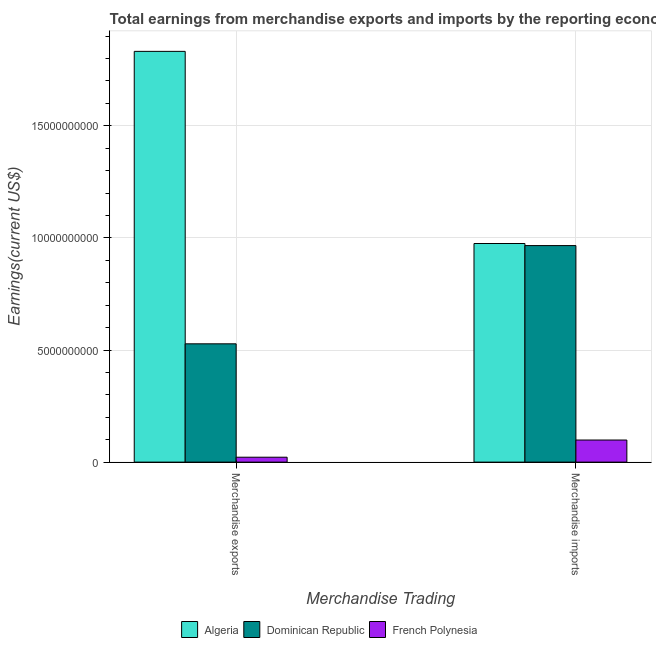Are the number of bars on each tick of the X-axis equal?
Give a very brief answer. Yes. How many bars are there on the 2nd tick from the left?
Provide a succinct answer. 3. How many bars are there on the 2nd tick from the right?
Make the answer very short. 3. What is the label of the 1st group of bars from the left?
Provide a short and direct response. Merchandise exports. What is the earnings from merchandise imports in Dominican Republic?
Provide a short and direct response. 9.66e+09. Across all countries, what is the maximum earnings from merchandise imports?
Keep it short and to the point. 9.75e+09. Across all countries, what is the minimum earnings from merchandise exports?
Make the answer very short. 2.19e+08. In which country was the earnings from merchandise imports maximum?
Your answer should be very brief. Algeria. In which country was the earnings from merchandise imports minimum?
Your response must be concise. French Polynesia. What is the total earnings from merchandise imports in the graph?
Ensure brevity in your answer.  2.04e+1. What is the difference between the earnings from merchandise exports in Algeria and that in Dominican Republic?
Your answer should be compact. 1.30e+1. What is the difference between the earnings from merchandise imports in Dominican Republic and the earnings from merchandise exports in Algeria?
Ensure brevity in your answer.  -8.66e+09. What is the average earnings from merchandise imports per country?
Provide a short and direct response. 6.80e+09. What is the difference between the earnings from merchandise imports and earnings from merchandise exports in Algeria?
Your response must be concise. -8.57e+09. In how many countries, is the earnings from merchandise imports greater than 11000000000 US$?
Offer a very short reply. 0. What is the ratio of the earnings from merchandise exports in French Polynesia to that in Dominican Republic?
Keep it short and to the point. 0.04. In how many countries, is the earnings from merchandise imports greater than the average earnings from merchandise imports taken over all countries?
Your response must be concise. 2. What does the 1st bar from the left in Merchandise exports represents?
Make the answer very short. Algeria. What does the 1st bar from the right in Merchandise exports represents?
Make the answer very short. French Polynesia. How many bars are there?
Make the answer very short. 6. Are all the bars in the graph horizontal?
Offer a terse response. No. How many countries are there in the graph?
Keep it short and to the point. 3. What is the difference between two consecutive major ticks on the Y-axis?
Offer a terse response. 5.00e+09. Are the values on the major ticks of Y-axis written in scientific E-notation?
Make the answer very short. No. Does the graph contain any zero values?
Offer a very short reply. No. Does the graph contain grids?
Give a very brief answer. Yes. Where does the legend appear in the graph?
Provide a short and direct response. Bottom center. What is the title of the graph?
Your answer should be very brief. Total earnings from merchandise exports and imports by the reporting economy in 2001. Does "Macao" appear as one of the legend labels in the graph?
Offer a very short reply. No. What is the label or title of the X-axis?
Your answer should be compact. Merchandise Trading. What is the label or title of the Y-axis?
Offer a very short reply. Earnings(current US$). What is the Earnings(current US$) of Algeria in Merchandise exports?
Your answer should be very brief. 1.83e+1. What is the Earnings(current US$) in Dominican Republic in Merchandise exports?
Your answer should be very brief. 5.28e+09. What is the Earnings(current US$) of French Polynesia in Merchandise exports?
Your response must be concise. 2.19e+08. What is the Earnings(current US$) of Algeria in Merchandise imports?
Offer a very short reply. 9.75e+09. What is the Earnings(current US$) in Dominican Republic in Merchandise imports?
Keep it short and to the point. 9.66e+09. What is the Earnings(current US$) in French Polynesia in Merchandise imports?
Your answer should be very brief. 9.86e+08. Across all Merchandise Trading, what is the maximum Earnings(current US$) in Algeria?
Provide a succinct answer. 1.83e+1. Across all Merchandise Trading, what is the maximum Earnings(current US$) of Dominican Republic?
Your answer should be compact. 9.66e+09. Across all Merchandise Trading, what is the maximum Earnings(current US$) of French Polynesia?
Provide a succinct answer. 9.86e+08. Across all Merchandise Trading, what is the minimum Earnings(current US$) in Algeria?
Offer a very short reply. 9.75e+09. Across all Merchandise Trading, what is the minimum Earnings(current US$) of Dominican Republic?
Keep it short and to the point. 5.28e+09. Across all Merchandise Trading, what is the minimum Earnings(current US$) in French Polynesia?
Ensure brevity in your answer.  2.19e+08. What is the total Earnings(current US$) in Algeria in the graph?
Give a very brief answer. 2.81e+1. What is the total Earnings(current US$) in Dominican Republic in the graph?
Provide a succinct answer. 1.49e+1. What is the total Earnings(current US$) in French Polynesia in the graph?
Ensure brevity in your answer.  1.20e+09. What is the difference between the Earnings(current US$) of Algeria in Merchandise exports and that in Merchandise imports?
Ensure brevity in your answer.  8.57e+09. What is the difference between the Earnings(current US$) in Dominican Republic in Merchandise exports and that in Merchandise imports?
Your response must be concise. -4.38e+09. What is the difference between the Earnings(current US$) of French Polynesia in Merchandise exports and that in Merchandise imports?
Provide a succinct answer. -7.67e+08. What is the difference between the Earnings(current US$) in Algeria in Merchandise exports and the Earnings(current US$) in Dominican Republic in Merchandise imports?
Offer a terse response. 8.66e+09. What is the difference between the Earnings(current US$) in Algeria in Merchandise exports and the Earnings(current US$) in French Polynesia in Merchandise imports?
Your answer should be very brief. 1.73e+1. What is the difference between the Earnings(current US$) of Dominican Republic in Merchandise exports and the Earnings(current US$) of French Polynesia in Merchandise imports?
Keep it short and to the point. 4.29e+09. What is the average Earnings(current US$) of Algeria per Merchandise Trading?
Ensure brevity in your answer.  1.40e+1. What is the average Earnings(current US$) of Dominican Republic per Merchandise Trading?
Provide a short and direct response. 7.47e+09. What is the average Earnings(current US$) of French Polynesia per Merchandise Trading?
Keep it short and to the point. 6.02e+08. What is the difference between the Earnings(current US$) of Algeria and Earnings(current US$) of Dominican Republic in Merchandise exports?
Offer a terse response. 1.30e+1. What is the difference between the Earnings(current US$) of Algeria and Earnings(current US$) of French Polynesia in Merchandise exports?
Ensure brevity in your answer.  1.81e+1. What is the difference between the Earnings(current US$) of Dominican Republic and Earnings(current US$) of French Polynesia in Merchandise exports?
Offer a very short reply. 5.06e+09. What is the difference between the Earnings(current US$) of Algeria and Earnings(current US$) of Dominican Republic in Merchandise imports?
Provide a succinct answer. 9.23e+07. What is the difference between the Earnings(current US$) of Algeria and Earnings(current US$) of French Polynesia in Merchandise imports?
Make the answer very short. 8.76e+09. What is the difference between the Earnings(current US$) in Dominican Republic and Earnings(current US$) in French Polynesia in Merchandise imports?
Make the answer very short. 8.67e+09. What is the ratio of the Earnings(current US$) of Algeria in Merchandise exports to that in Merchandise imports?
Provide a succinct answer. 1.88. What is the ratio of the Earnings(current US$) in Dominican Republic in Merchandise exports to that in Merchandise imports?
Give a very brief answer. 0.55. What is the ratio of the Earnings(current US$) of French Polynesia in Merchandise exports to that in Merchandise imports?
Provide a short and direct response. 0.22. What is the difference between the highest and the second highest Earnings(current US$) in Algeria?
Keep it short and to the point. 8.57e+09. What is the difference between the highest and the second highest Earnings(current US$) in Dominican Republic?
Offer a very short reply. 4.38e+09. What is the difference between the highest and the second highest Earnings(current US$) of French Polynesia?
Provide a short and direct response. 7.67e+08. What is the difference between the highest and the lowest Earnings(current US$) of Algeria?
Ensure brevity in your answer.  8.57e+09. What is the difference between the highest and the lowest Earnings(current US$) of Dominican Republic?
Offer a very short reply. 4.38e+09. What is the difference between the highest and the lowest Earnings(current US$) of French Polynesia?
Ensure brevity in your answer.  7.67e+08. 